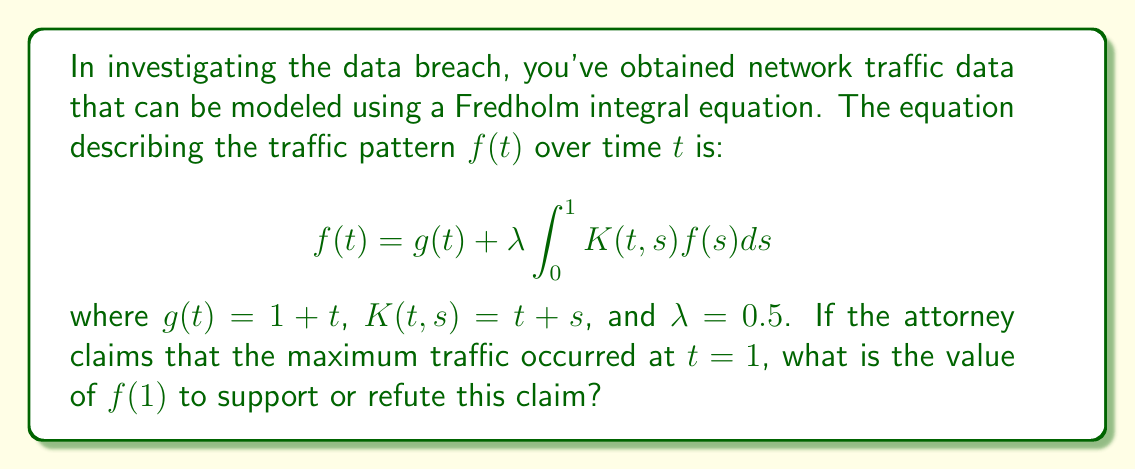Can you answer this question? To solve this problem, we need to follow these steps:

1) First, we need to substitute the given values into the Fredholm integral equation:

   $$f(t) = (1 + t) + 0.5 \int_0^1 (t + s)f(s)ds$$

2) We're interested in $f(1)$, so let's substitute $t = 1$:

   $$f(1) = (1 + 1) + 0.5 \int_0^1 (1 + s)f(s)ds$$

3) Simplify:

   $$f(1) = 2 + 0.5 \int_0^1 (1 + s)f(s)ds$$

4) Now, we need to solve this equation. Let's define:

   $$I = \int_0^1 f(s)ds \quad \text{and} \quad J = \int_0^1 sf(s)ds$$

5) Using these definitions, we can rewrite our equation as:

   $$f(1) = 2 + 0.5(I + J)$$

6) Now, let's integrate both sides of our original equation from 0 to 1:

   $$\int_0^1 f(t)dt = \int_0^1 (1 + t)dt + 0.5 \int_0^1 \int_0^1 (t + s)f(s)ds dt$$

7) This gives us:

   $$I = \frac{3}{2} + 0.5(I + J)$$

8) Similarly, if we multiply both sides of our original equation by $t$ and then integrate from 0 to 1:

   $$\int_0^1 tf(t)dt = \int_0^1 t(1 + t)dt + 0.5 \int_0^1 \int_0^1 t(t + s)f(s)ds dt$$

9) This gives us:

   $$J = \frac{7}{6} + 0.5(\frac{1}{2}I + \frac{1}{3}J)$$

10) We now have a system of three equations:

    $$f(1) = 2 + 0.5(I + J)$$
    $$I = \frac{3}{2} + 0.5(I + J)$$
    $$J = \frac{7}{6} + 0.5(\frac{1}{2}I + \frac{1}{3}J)$$

11) Solving this system (which involves some algebra), we get:

    $$I = 2, \quad J = \frac{5}{3}, \quad f(1) = \frac{13}{6}$$

Therefore, the value of $f(1)$ is $\frac{13}{6}$ or approximately 2.1667.
Answer: $\frac{13}{6}$ 